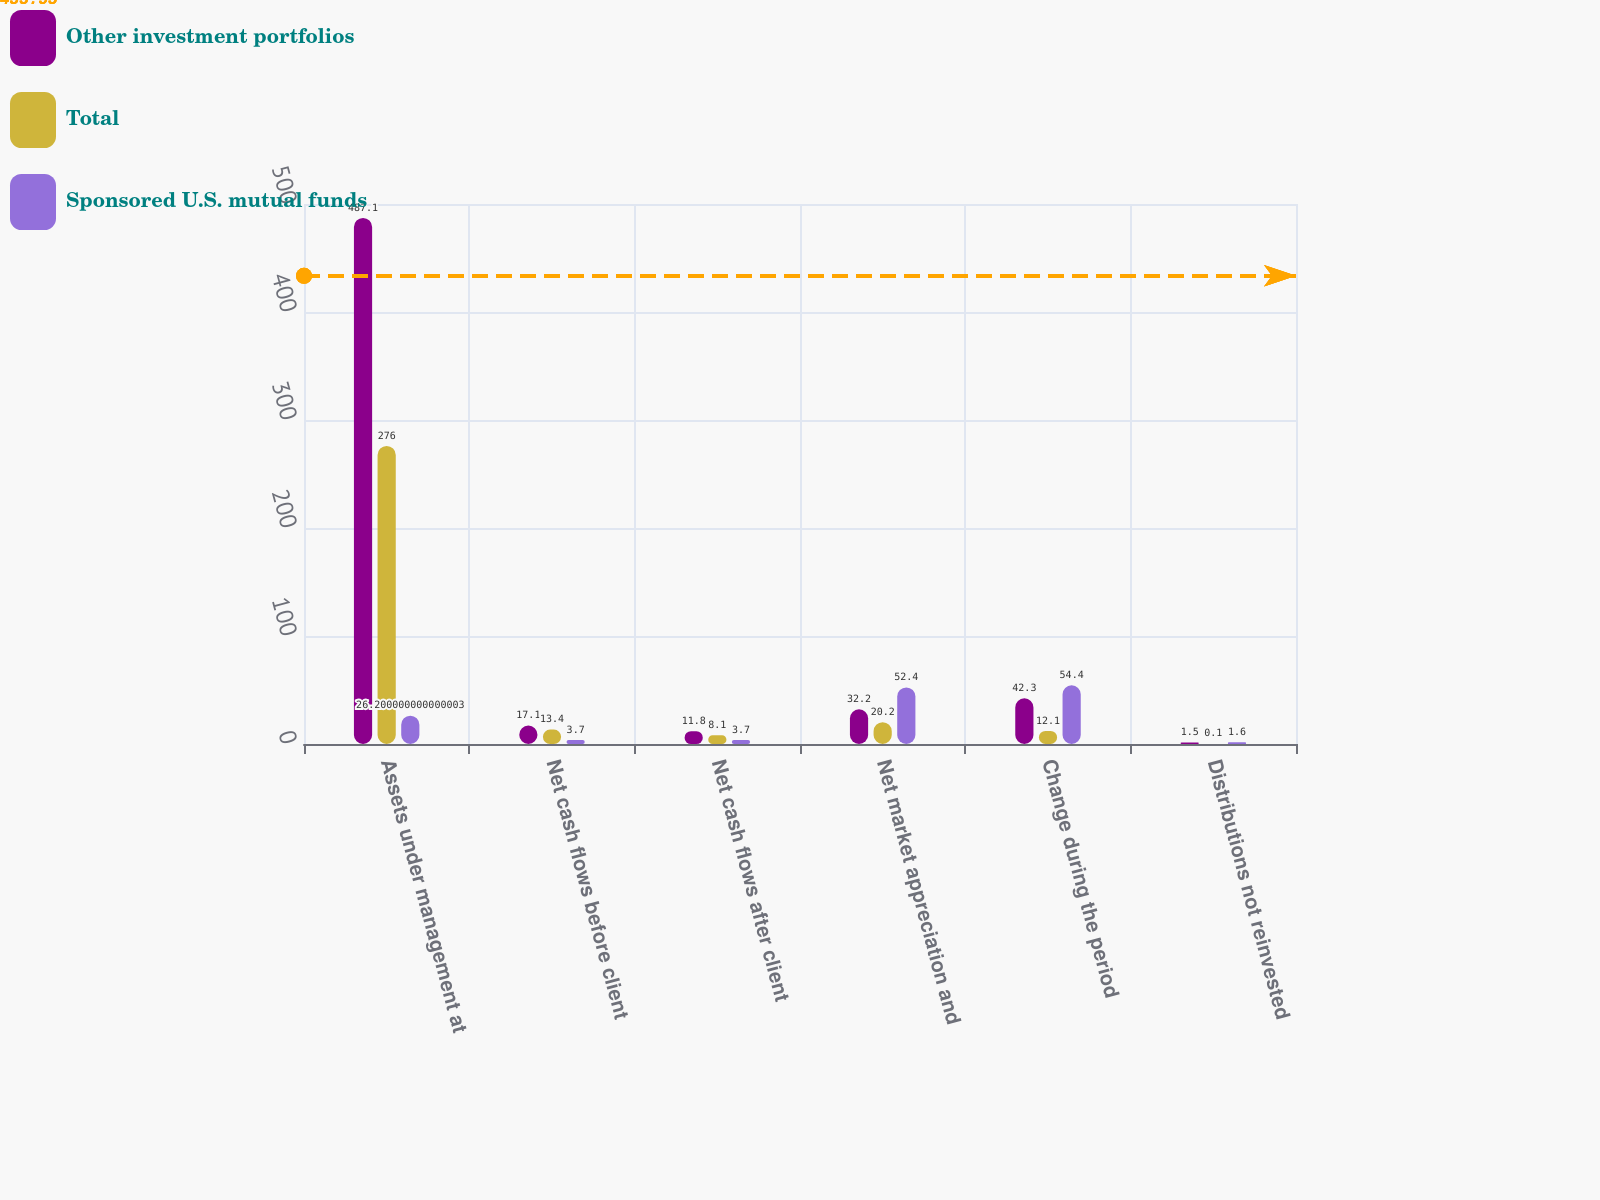Convert chart to OTSL. <chart><loc_0><loc_0><loc_500><loc_500><stacked_bar_chart><ecel><fcel>Assets under management at<fcel>Net cash flows before client<fcel>Net cash flows after client<fcel>Net market appreciation and<fcel>Change during the period<fcel>Distributions not reinvested<nl><fcel>Other investment portfolios<fcel>487.1<fcel>17.1<fcel>11.8<fcel>32.2<fcel>42.3<fcel>1.5<nl><fcel>Total<fcel>276<fcel>13.4<fcel>8.1<fcel>20.2<fcel>12.1<fcel>0.1<nl><fcel>Sponsored U.S. mutual funds<fcel>26.2<fcel>3.7<fcel>3.7<fcel>52.4<fcel>54.4<fcel>1.6<nl></chart> 